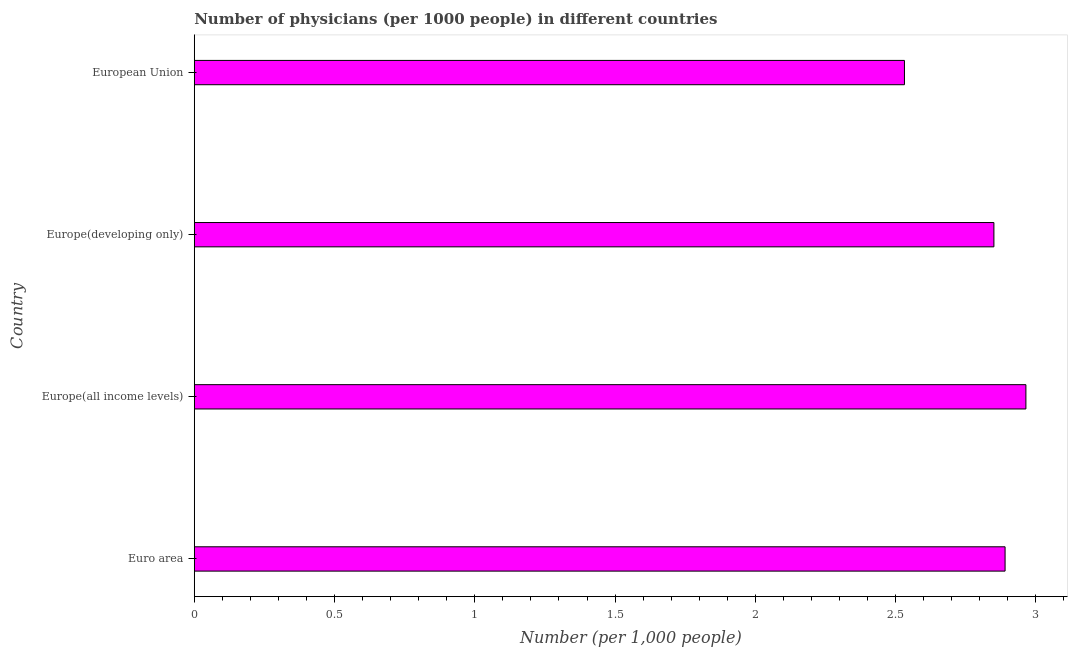What is the title of the graph?
Your response must be concise. Number of physicians (per 1000 people) in different countries. What is the label or title of the X-axis?
Offer a very short reply. Number (per 1,0 people). What is the number of physicians in European Union?
Offer a terse response. 2.53. Across all countries, what is the maximum number of physicians?
Ensure brevity in your answer.  2.96. Across all countries, what is the minimum number of physicians?
Provide a short and direct response. 2.53. In which country was the number of physicians maximum?
Offer a terse response. Europe(all income levels). What is the sum of the number of physicians?
Make the answer very short. 11.24. What is the difference between the number of physicians in Europe(all income levels) and European Union?
Ensure brevity in your answer.  0.43. What is the average number of physicians per country?
Your response must be concise. 2.81. What is the median number of physicians?
Give a very brief answer. 2.87. In how many countries, is the number of physicians greater than 3 ?
Make the answer very short. 0. What is the ratio of the number of physicians in Euro area to that in Europe(all income levels)?
Keep it short and to the point. 0.97. Is the number of physicians in Europe(all income levels) less than that in European Union?
Offer a terse response. No. What is the difference between the highest and the second highest number of physicians?
Your answer should be very brief. 0.07. Is the sum of the number of physicians in Euro area and Europe(all income levels) greater than the maximum number of physicians across all countries?
Ensure brevity in your answer.  Yes. What is the difference between the highest and the lowest number of physicians?
Offer a terse response. 0.43. What is the difference between two consecutive major ticks on the X-axis?
Your answer should be compact. 0.5. What is the Number (per 1,000 people) of Euro area?
Offer a very short reply. 2.89. What is the Number (per 1,000 people) in Europe(all income levels)?
Your answer should be compact. 2.96. What is the Number (per 1,000 people) in Europe(developing only)?
Give a very brief answer. 2.85. What is the Number (per 1,000 people) of European Union?
Offer a terse response. 2.53. What is the difference between the Number (per 1,000 people) in Euro area and Europe(all income levels)?
Your response must be concise. -0.07. What is the difference between the Number (per 1,000 people) in Euro area and Europe(developing only)?
Ensure brevity in your answer.  0.04. What is the difference between the Number (per 1,000 people) in Euro area and European Union?
Provide a succinct answer. 0.36. What is the difference between the Number (per 1,000 people) in Europe(all income levels) and Europe(developing only)?
Keep it short and to the point. 0.11. What is the difference between the Number (per 1,000 people) in Europe(all income levels) and European Union?
Your answer should be compact. 0.43. What is the difference between the Number (per 1,000 people) in Europe(developing only) and European Union?
Your response must be concise. 0.32. What is the ratio of the Number (per 1,000 people) in Euro area to that in Europe(all income levels)?
Give a very brief answer. 0.97. What is the ratio of the Number (per 1,000 people) in Euro area to that in European Union?
Ensure brevity in your answer.  1.14. What is the ratio of the Number (per 1,000 people) in Europe(all income levels) to that in Europe(developing only)?
Your response must be concise. 1.04. What is the ratio of the Number (per 1,000 people) in Europe(all income levels) to that in European Union?
Your answer should be very brief. 1.17. What is the ratio of the Number (per 1,000 people) in Europe(developing only) to that in European Union?
Provide a short and direct response. 1.13. 